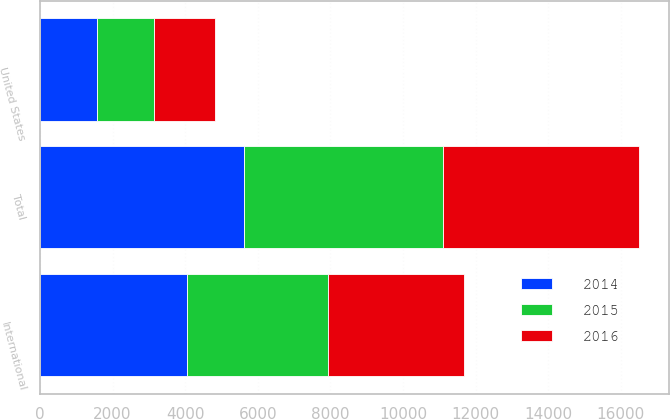Convert chart. <chart><loc_0><loc_0><loc_500><loc_500><stacked_bar_chart><ecel><fcel>United States<fcel>International<fcel>Total<nl><fcel>2016<fcel>1672.9<fcel>3750<fcel>5422.9<nl><fcel>2015<fcel>1584.7<fcel>3899<fcel>5483.7<nl><fcel>2014<fcel>1564.6<fcel>4042.6<fcel>5607.2<nl></chart> 